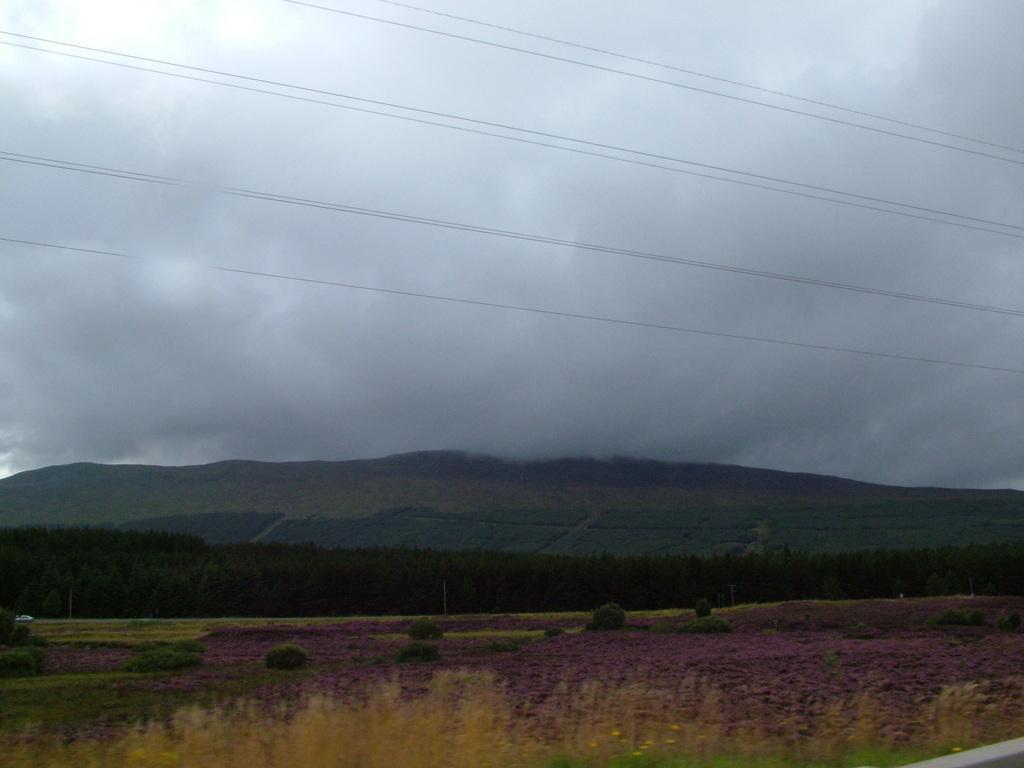Could you give a brief overview of what you see in this image? In this image I see the plants in front and I see the wires over here. In the background I see the trees, mountains and the sky which is cloudy. 